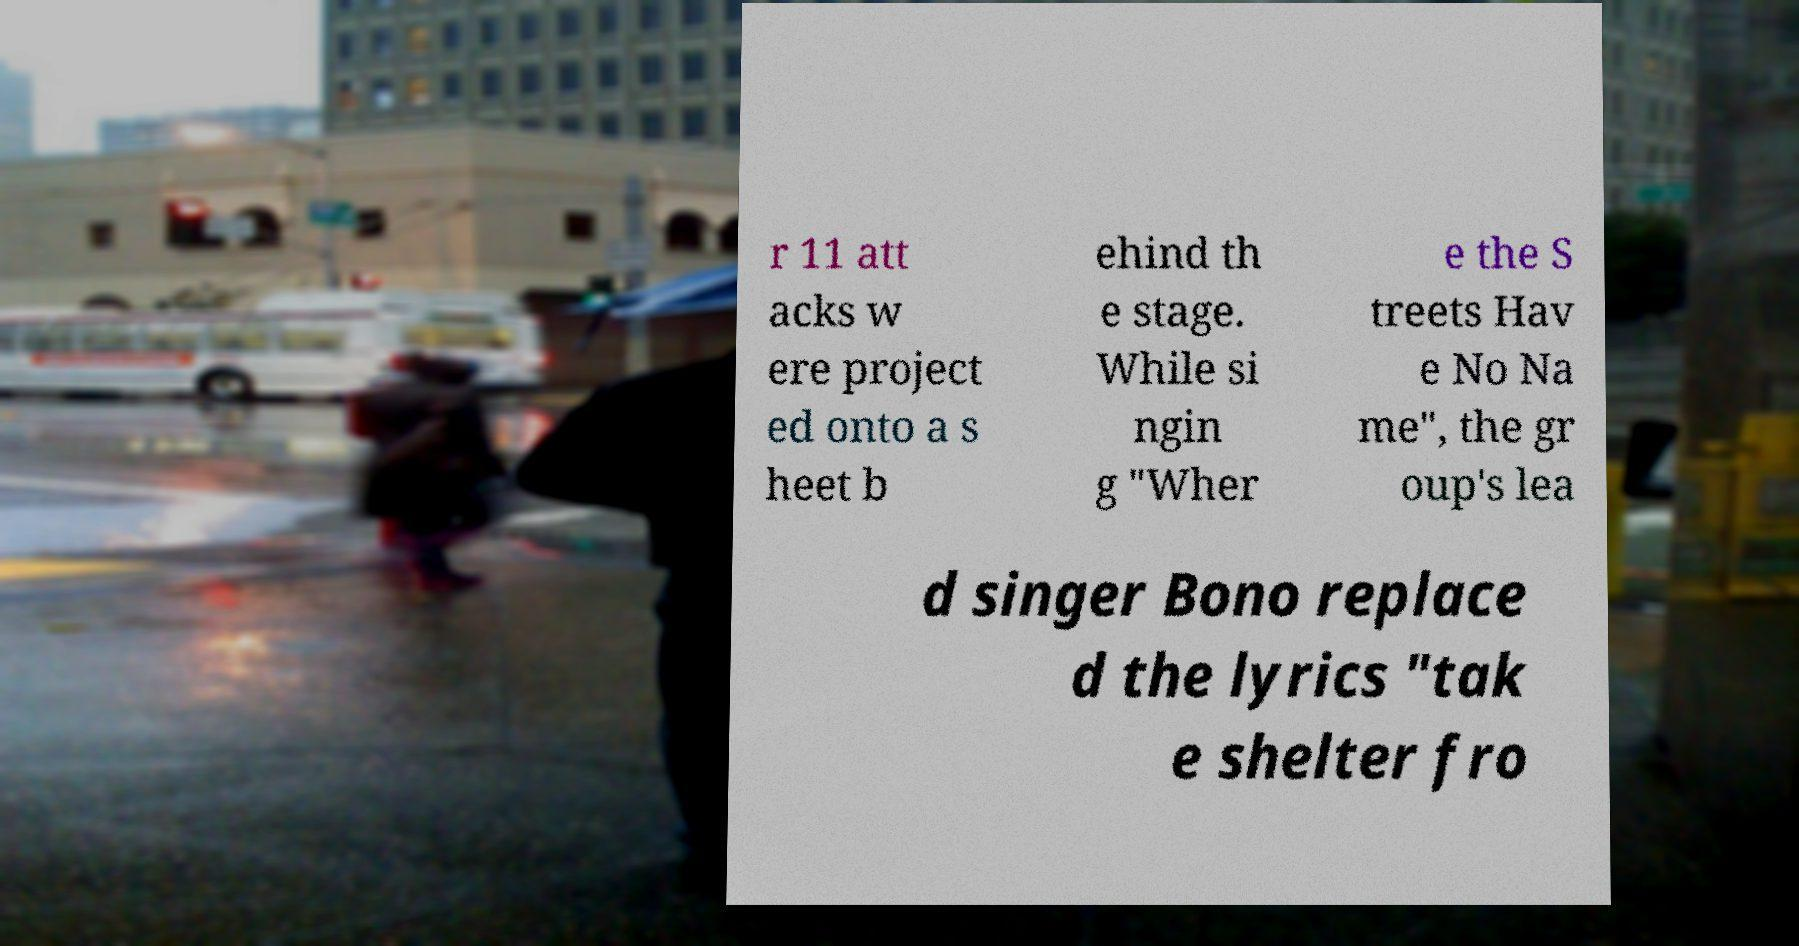What messages or text are displayed in this image? I need them in a readable, typed format. r 11 att acks w ere project ed onto a s heet b ehind th e stage. While si ngin g "Wher e the S treets Hav e No Na me", the gr oup's lea d singer Bono replace d the lyrics "tak e shelter fro 